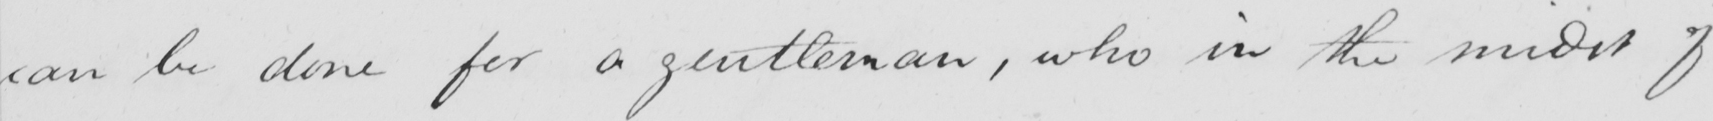Can you read and transcribe this handwriting? can be done for a gentleman , who in the midst of 